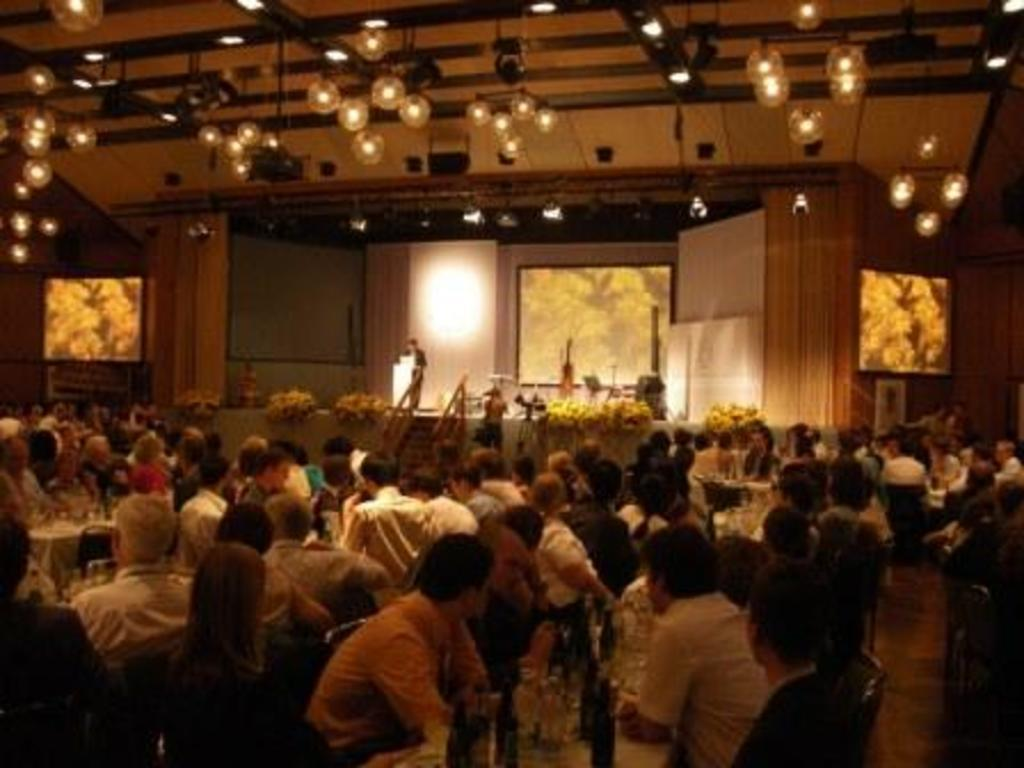What is happening in the image involving the people and chairs? There are people sitting on chairs around a dining table. What can be seen on the table besides the chairs? There are wine glasses on the table. What is the person standing near doing? The person is standing near a podium. Where is this scene taking place? The scene appears to be on a stage. What type of weather can be seen in the image? There is no weather visible in the image, as it is an indoor scene. What is the fuel source for the podium in the image? There is no fuel source for the podium in the image, as it is a stationary object. 